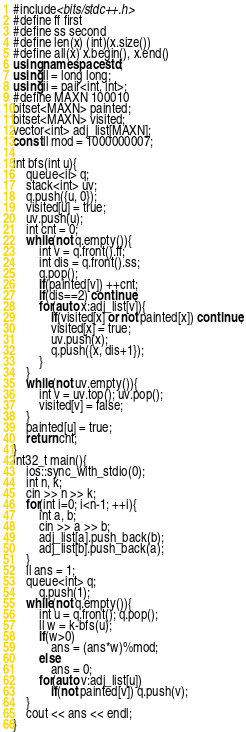<code> <loc_0><loc_0><loc_500><loc_500><_C++_>#include<bits/stdc++.h>
#define ff first
#define ss second
#define len(x) (int)(x.size())
#define all(x) x.begin(), x.end()
using namespace std;
using ll = long long;
using ii = pair<int, int>;
#define MAXN 100010 
bitset<MAXN> painted;
bitset<MAXN> visited;
vector<int> adj_list[MAXN];
const ll mod = 1000000007;

int bfs(int u){
	queue<ii> q;
	stack<int> uv;
	q.push({u, 0});
	visited[u] = true;
	uv.push(u);
	int cnt = 0;
	while(not q.empty()){
		int v = q.front().ff;
		int dis = q.front().ss; 
		q.pop();
		if(painted[v]) ++cnt;
		if(dis==2) continue;
		for(auto x:adj_list[v]){
			if(visited[x] or not painted[x]) continue;
			visited[x] = true;
			uv.push(x);
			q.push({x, dis+1});
		}
	}
	while(not uv.empty()){
		int v = uv.top(); uv.pop();
		visited[v] = false;
	}
	painted[u] = true;
	return cnt;
}
int32_t main(){
	ios::sync_with_stdio(0);
	int n, k;
	cin >> n >> k;
	for(int i=0; i<n-1; ++i){
		int a, b;
		cin >> a >> b;
		adj_list[a].push_back(b);	
		adj_list[b].push_back(a);
	}
	ll ans = 1;
	queue<int> q;
       	q.push(1);
	while(not q.empty()){
		int u = q.front(); q.pop();
		ll w = k-bfs(u);
		if(w>0)
			ans = (ans*w)%mod;
		else
			ans = 0;
		for(auto v:adj_list[u])
			if(not painted[v]) q.push(v);
	}
	cout << ans << endl;
}
</code> 